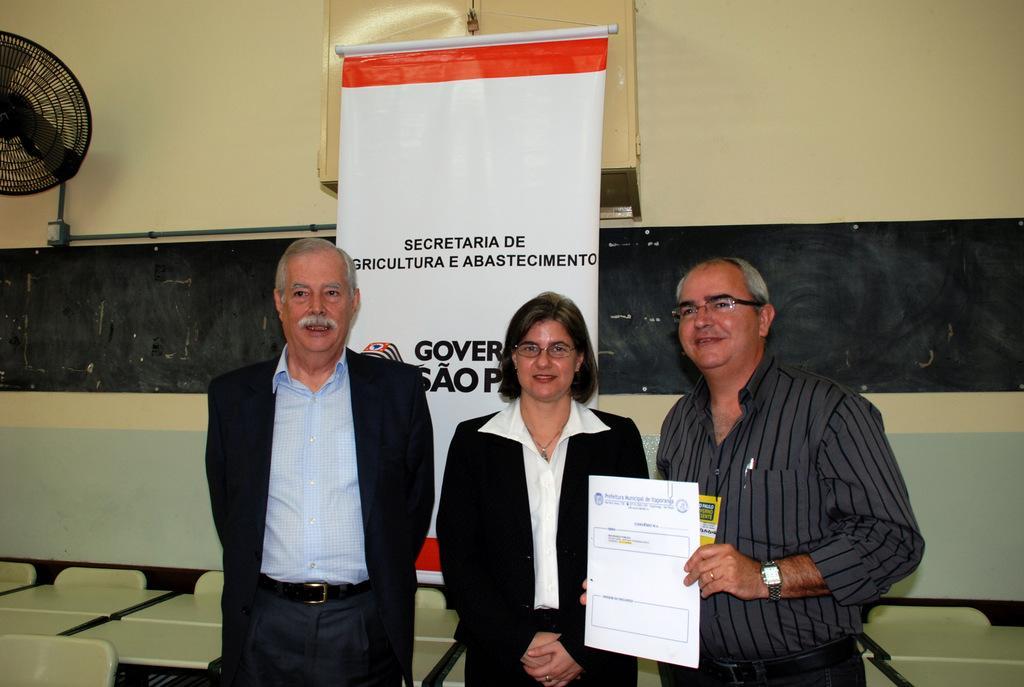Could you give a brief overview of what you see in this image? In the foreground of the picture there are three people standing, behind them there are tables and a banner. At the top there are fan, pipe, window and wall. 